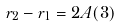<formula> <loc_0><loc_0><loc_500><loc_500>r _ { 2 } - r _ { 1 } = 2 A ( 3 )</formula> 